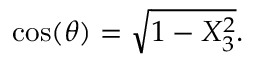<formula> <loc_0><loc_0><loc_500><loc_500>\cos ( \theta ) = { \sqrt { 1 - X _ { 3 } ^ { 2 } } } .</formula> 